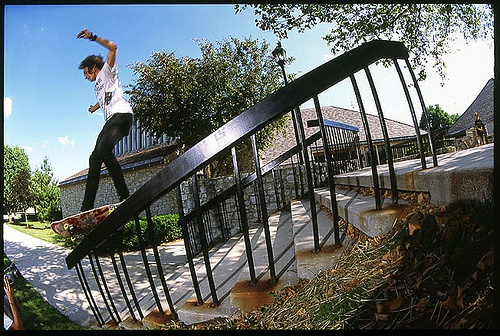Describe the objects in this image and their specific colors. I can see people in black, lavender, darkgray, and gray tones, skateboard in black, maroon, and gray tones, and people in black, gray, and maroon tones in this image. 